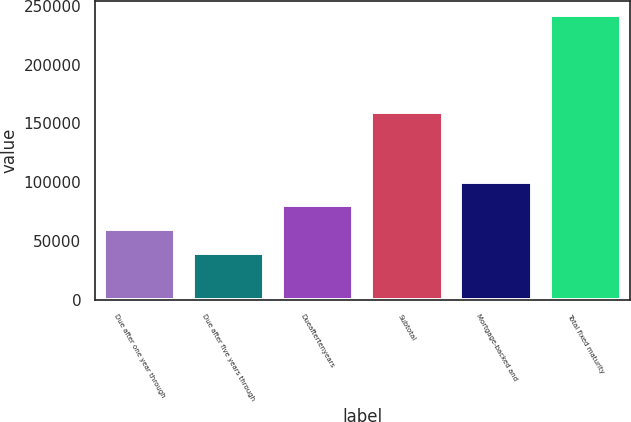Convert chart to OTSL. <chart><loc_0><loc_0><loc_500><loc_500><bar_chart><fcel>Due after one year through<fcel>Due after five years through<fcel>Dueaftertenyears<fcel>Subtotal<fcel>Mortgage-backed and<fcel>Total fixed maturity<nl><fcel>60372.8<fcel>40200<fcel>80545.6<fcel>159867<fcel>100718<fcel>241928<nl></chart> 